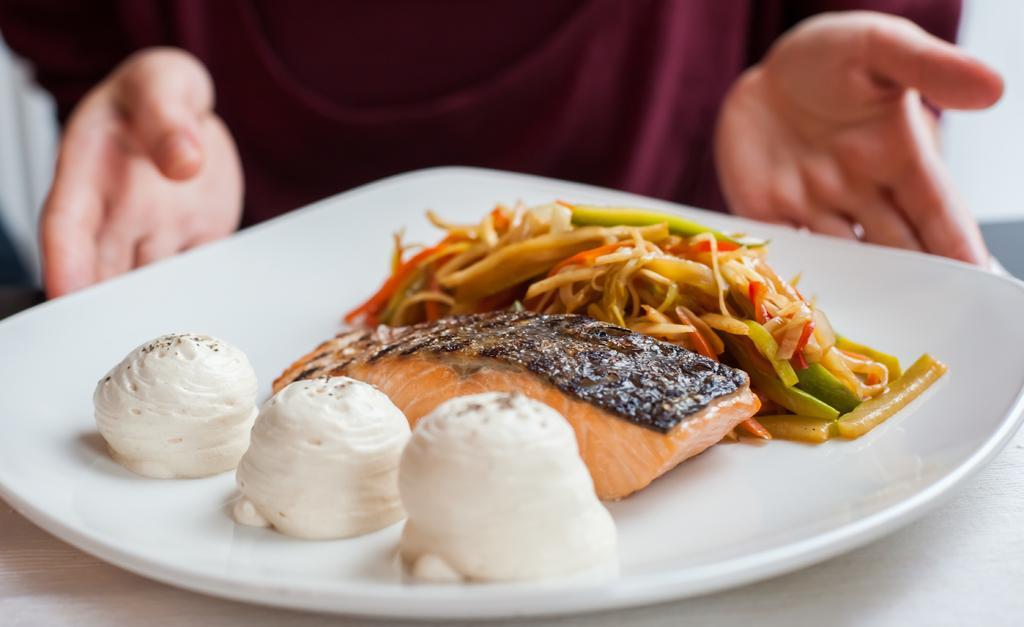Please provide a concise description of this image. In this image I can see a person holding a plate which consists of some food items. This plate is placed on a wooden surface. 